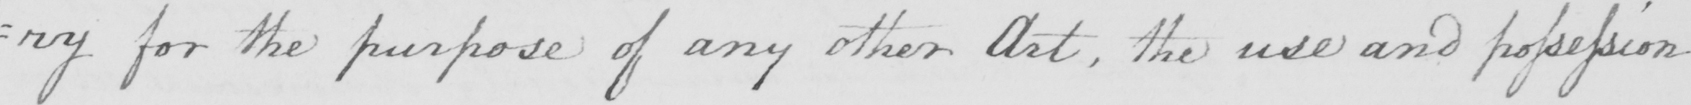Please provide the text content of this handwritten line. =ry for the purpose of any other Art  , the use and possession 